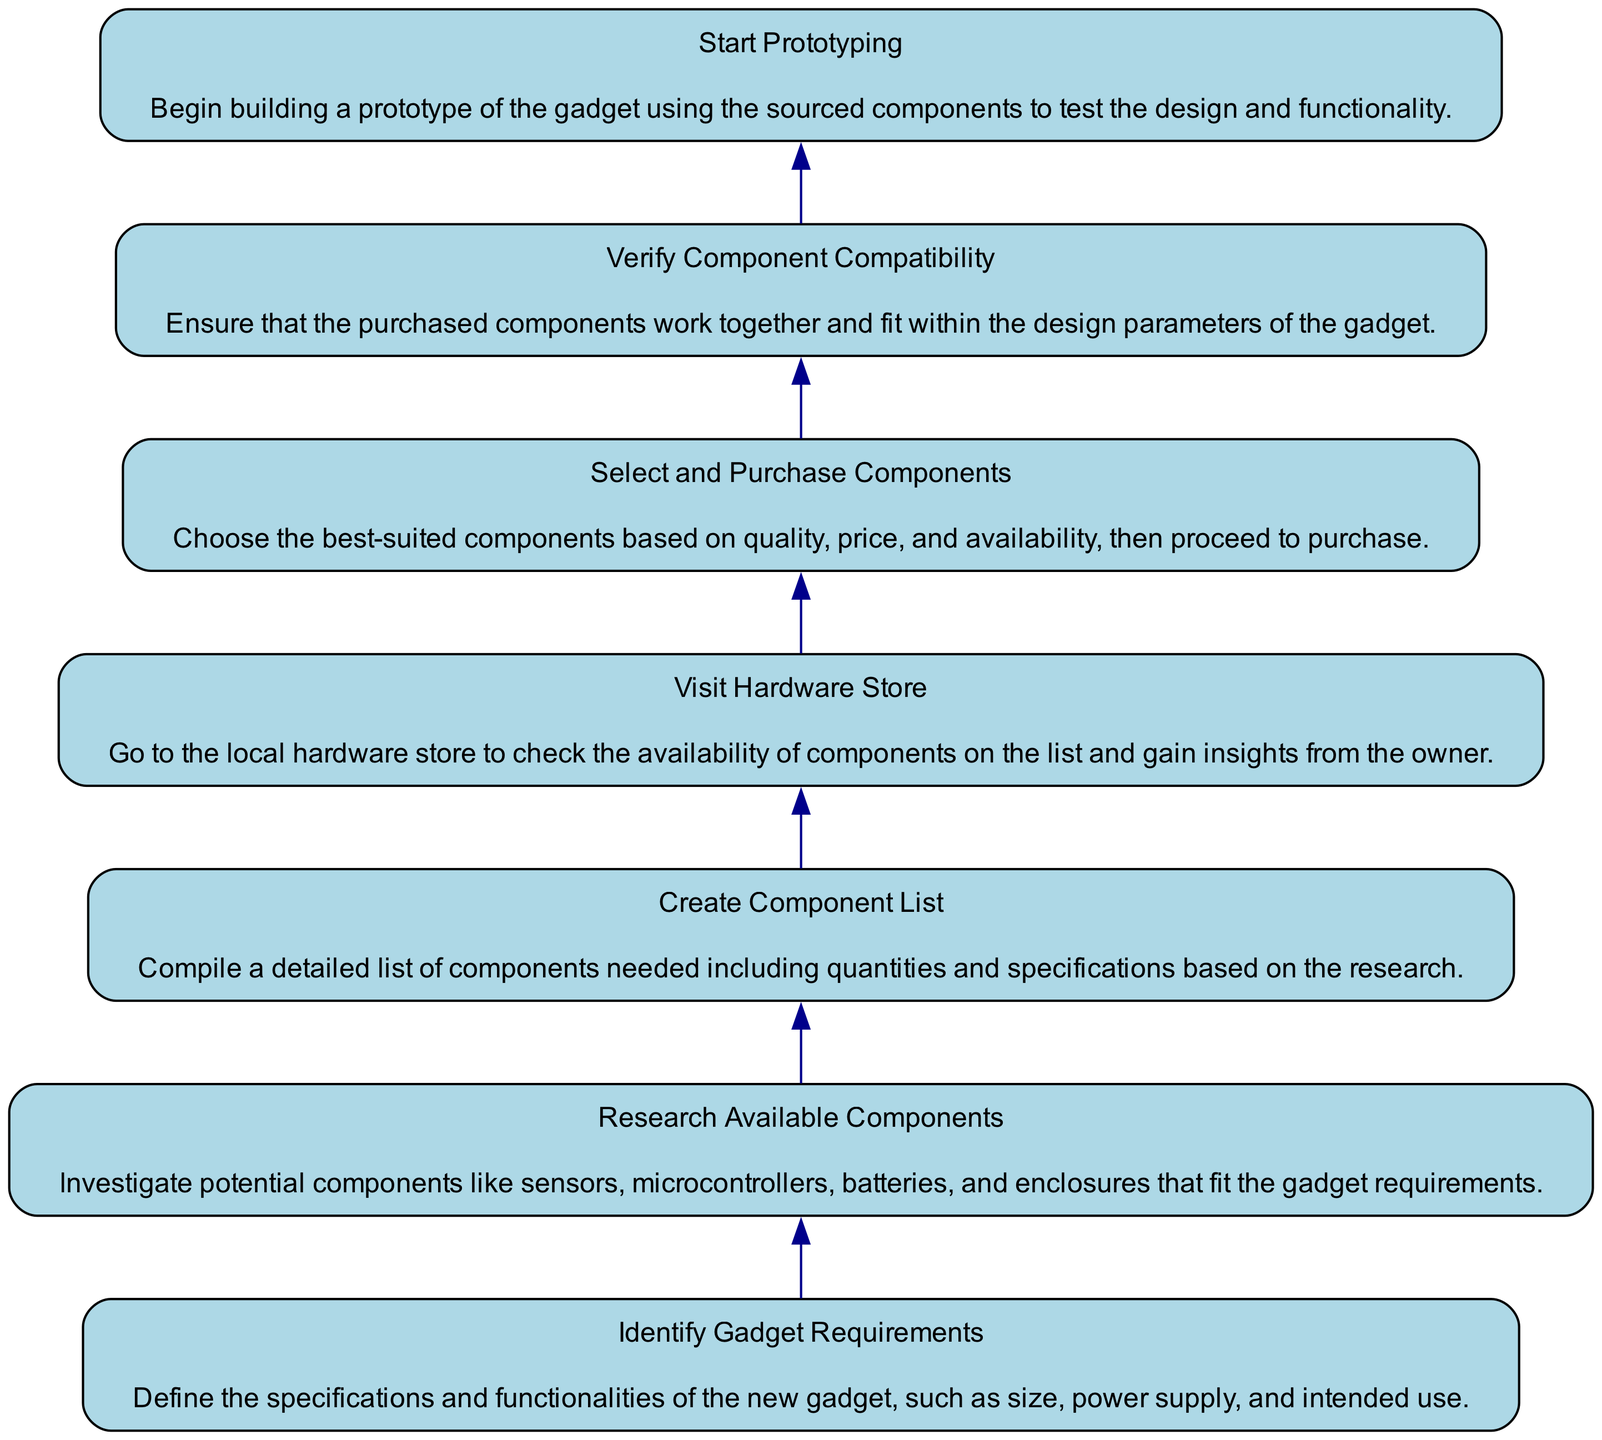What is the first step in the component sourcing process? The diagram starts with the "Identify Gadget Requirements" node, which indicates that this is the first step in the process of sourcing components for a new gadget design.
Answer: Identify Gadget Requirements How many total nodes are present in the diagram? The diagram contains seven nodes, each representing a step in the component sourcing process, starting from identifying requirements to starting prototyping.
Answer: Seven Which step involves checking the availability of components? The "Visit Hardware Store" step specifically denotes the action of going to the local hardware store to check if the components from the list are available.
Answer: Visit Hardware Store What is the last step in the process? The last node in the flow chart illustrates that "Start Prototyping" is the ultimate action taken after sourcing the components.
Answer: Start Prototyping Which two steps are directly connected by an edge in the flowchart? The "Select and Purchase Components" and "Verify Component Compatibility" steps are sequentially connected, indicating that after purchasing, it is important to verify their compatibility.
Answer: Select and Purchase Components and Verify Component Compatibility What action is taken after creating a component list? The diagram indicates that after "Create Component List," the next action is to "Visit Hardware Store" to source the components listed.
Answer: Visit Hardware Store Why is it necessary to verify component compatibility? The diagram emphasizes the need to ensure that the components work well together and fit within the gadget's design parameters, which is crucial for successful gadget functionality.
Answer: To ensure functionality How do the steps progress from one to the next in the diagram? The diagram flows in a bottom-up manner from identifying requirements to prototyping, illustrating a clear sequence where each step logically leads to the next step in the sourcing process.
Answer: Sequentially from bottom to top 